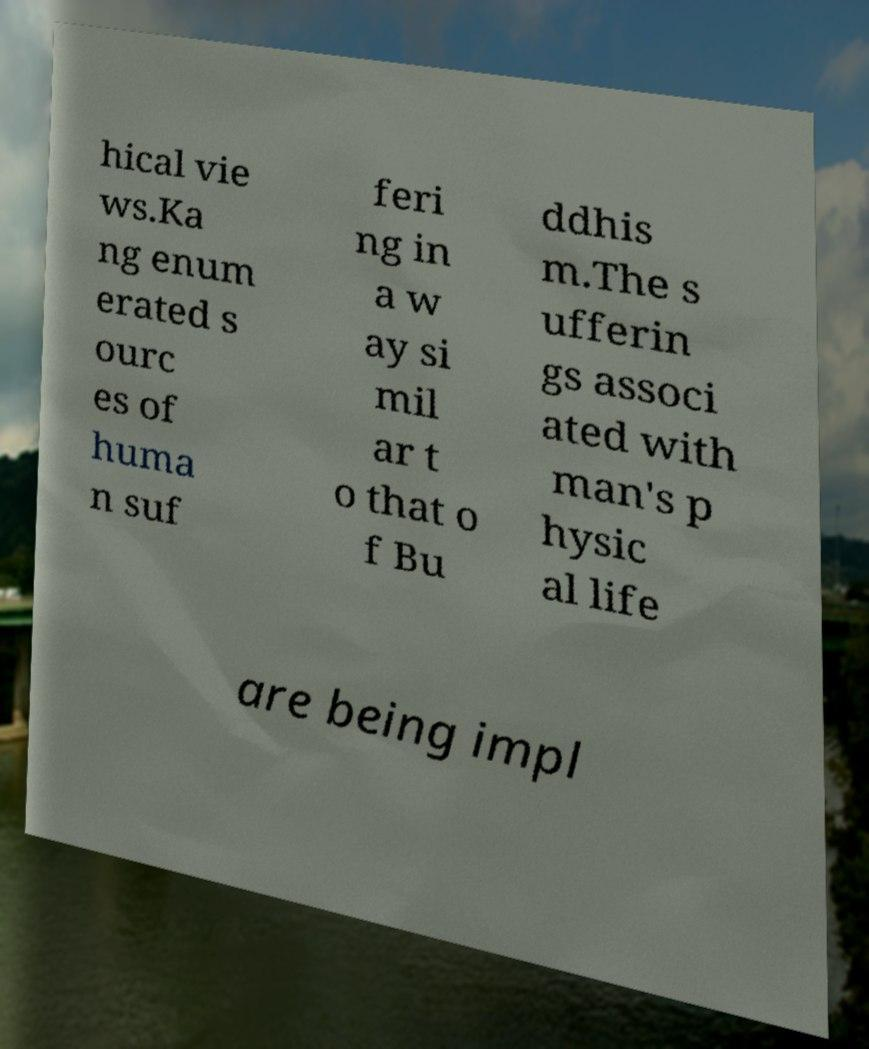Could you extract and type out the text from this image? hical vie ws.Ka ng enum erated s ourc es of huma n suf feri ng in a w ay si mil ar t o that o f Bu ddhis m.The s ufferin gs associ ated with man's p hysic al life are being impl 